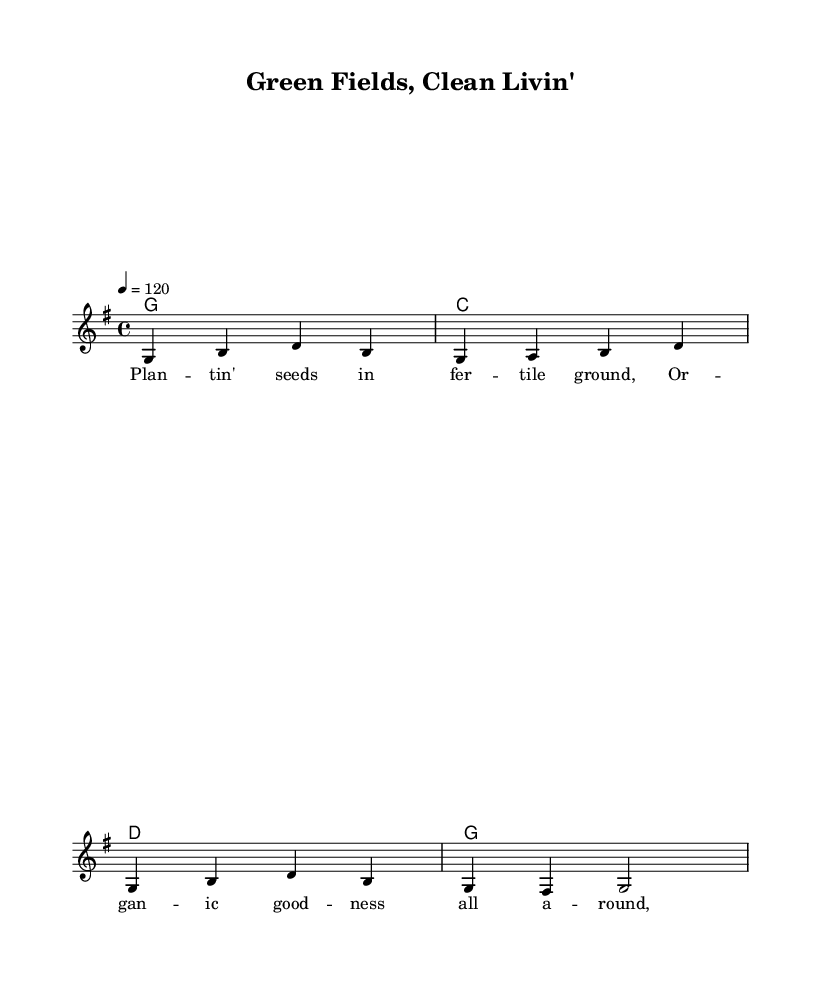What is the key signature of this music? The key signature is G major, which has one sharp (F#). This is indicated at the beginning of the staff in the sheet music.
Answer: G major What is the time signature of this piece? The time signature is 4/4, indicating that there are four beats in each measure and the quarter note gets one beat. It is shown at the beginning of the sheet music.
Answer: 4/4 What is the tempo marking for this music? The tempo marking indicates a speed of 120 beats per minute (bpm), which is noted as "4 = 120" in the score. This tells the performer how quickly to play the piece.
Answer: 120 How many measures are present in the melody? The melody consists of 4 measures. This can be counted by observing the vertical lines (bar lines) that separate the measures in the music.
Answer: 4 What is the first chord played in the piece? The first chord is G major. This can be determined from the chord symbols listed above the staff, starting with G at the beginning of the piece.
Answer: G What is the main theme of the lyrics? The main theme of the lyrics focuses on sustainable farming and organic produce. This can be inferred from the phrases like "planting seeds in fertile ground" and "organic goodness all around."
Answer: Sustainable farming Which musical style is represented by this piece? The musical style is Country Rock, as it combines elements of country music with rock music, which is reflected in the upbeat tempo and lyrical content about farming.
Answer: Country Rock 